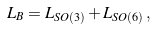<formula> <loc_0><loc_0><loc_500><loc_500>L _ { B } = L _ { S O ( 3 ) } + L _ { S O ( 6 ) } \, ,</formula> 